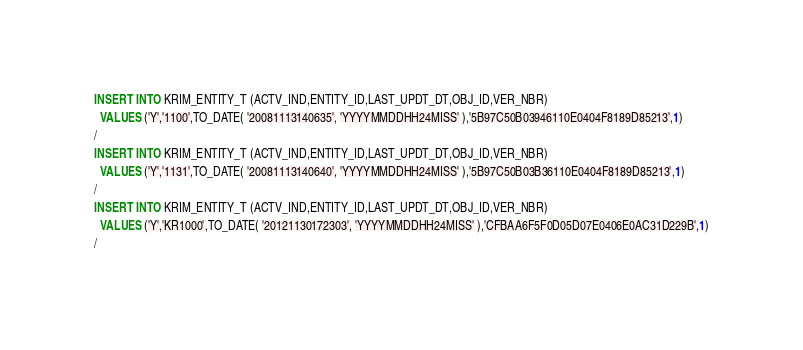Convert code to text. <code><loc_0><loc_0><loc_500><loc_500><_SQL_>INSERT INTO KRIM_ENTITY_T (ACTV_IND,ENTITY_ID,LAST_UPDT_DT,OBJ_ID,VER_NBR)
  VALUES ('Y','1100',TO_DATE( '20081113140635', 'YYYYMMDDHH24MISS' ),'5B97C50B03946110E0404F8189D85213',1)
/
INSERT INTO KRIM_ENTITY_T (ACTV_IND,ENTITY_ID,LAST_UPDT_DT,OBJ_ID,VER_NBR)
  VALUES ('Y','1131',TO_DATE( '20081113140640', 'YYYYMMDDHH24MISS' ),'5B97C50B03B36110E0404F8189D85213',1)
/
INSERT INTO KRIM_ENTITY_T (ACTV_IND,ENTITY_ID,LAST_UPDT_DT,OBJ_ID,VER_NBR)
  VALUES ('Y','KR1000',TO_DATE( '20121130172303', 'YYYYMMDDHH24MISS' ),'CFBAA6F5F0D05D07E0406E0AC31D229B',1)
/
</code> 